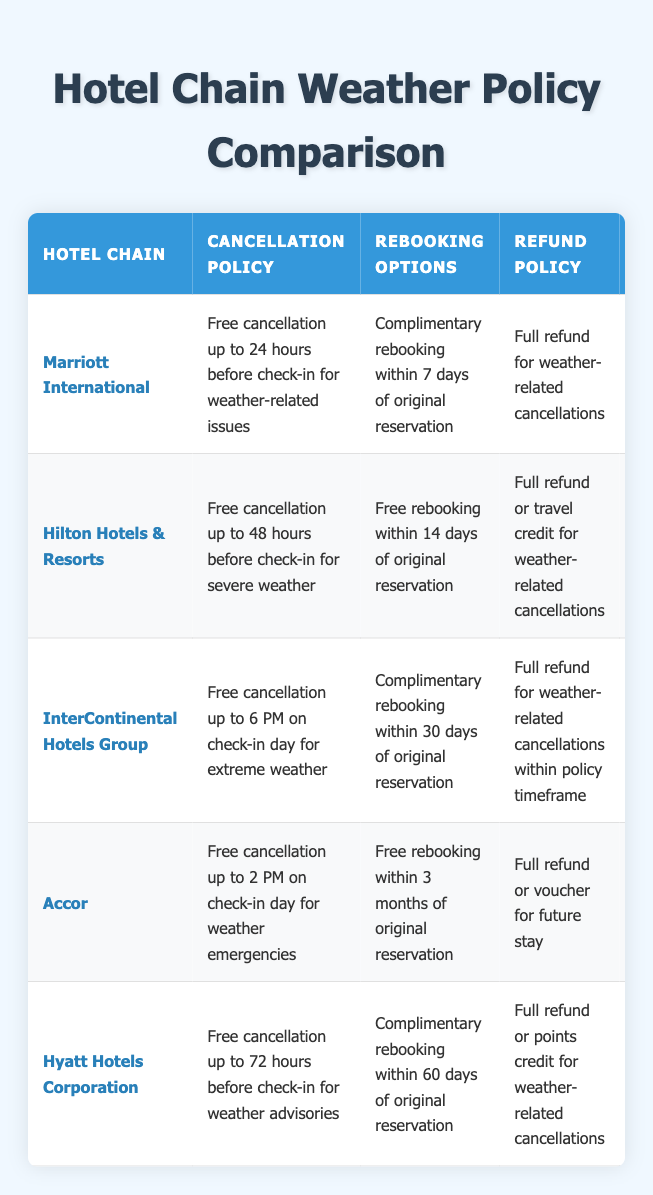What is the cancellation policy of Hilton Hotels & Resorts? The table specifies that Hilton Hotels & Resorts has a cancellation policy of "Free cancellation up to 48 hours before check-in for severe weather." This is a direct retrieval from the policy column for Hilton.
Answer: Free cancellation up to 48 hours before check-in for severe weather Which hotel chain offers a full refund or travel credit for weather-related cancellations? The table reveals that Hilton Hotels & Resorts provides either "Full refund or travel credit for weather-related cancellations." It can be located in the refund policy column under Hilton.
Answer: Hilton Hotels & Resorts What is the flexibility rating of Accor? From the table, Accor has a flexibility rating of 4.3, which can be found in the flexibility rating column associated with Accor.
Answer: 4.3 How many hotel chains allow free rebooking within 30 days of the original reservation? InterContinental Hotels Group is the only hotel chain that allows "Complimentary rebooking within 30 days of original reservation" according to the rebooking options column, making the total count one.
Answer: 1 Does Marriott International offer in-house travel insurance? The table indicates that Marriott International "Offers optional weather protection plan," which implies that they do have a form of travel insurance, although it's optional and not stated if it's in-house. This qualifies it as a yes.
Answer: Yes Which hotel has the most flexible cancellation policy regarding the latest time for cancellation? By examining the cancellation policies, InterContinental Hotels Group has the latest cancellation time, allowing free cancellation up to 6 PM on the check-in day for extreme weather, compared to others.
Answer: InterContinental Hotels Group What is the average flexibility rating among the listed hotel chains? Adding the flexibility ratings: 4.5 (Marriott) + 4.2 (Hilton) + 4.0 (InterContinental) + 4.3 (Accor) + 4.4 (Hyatt) makes 21.4. There are 5 hotel chains, so calculating the average gives 21.4 / 5 = 4.28.
Answer: 4.28 How does Accor's cancellation policy compare to Hyatt's in terms of time allowed? Accor allows free cancellation up to 2 PM on check-in day, whereas Hyatt allows up to 72 hours before check-in. This indicates Hyatt has a longer lead time for cancellation; thus, both policies serve different urgencies.
Answer: Hyatt allows longer lead time Which hotel chain has the most favorable rebooking options duration? Accor's free rebooking option of "within 3 months of original reservation" is more favorable compared to the other chains, which range from 7 days to 60 days. This indicates it has the longest flexibility for rebooking.
Answer: Accor 